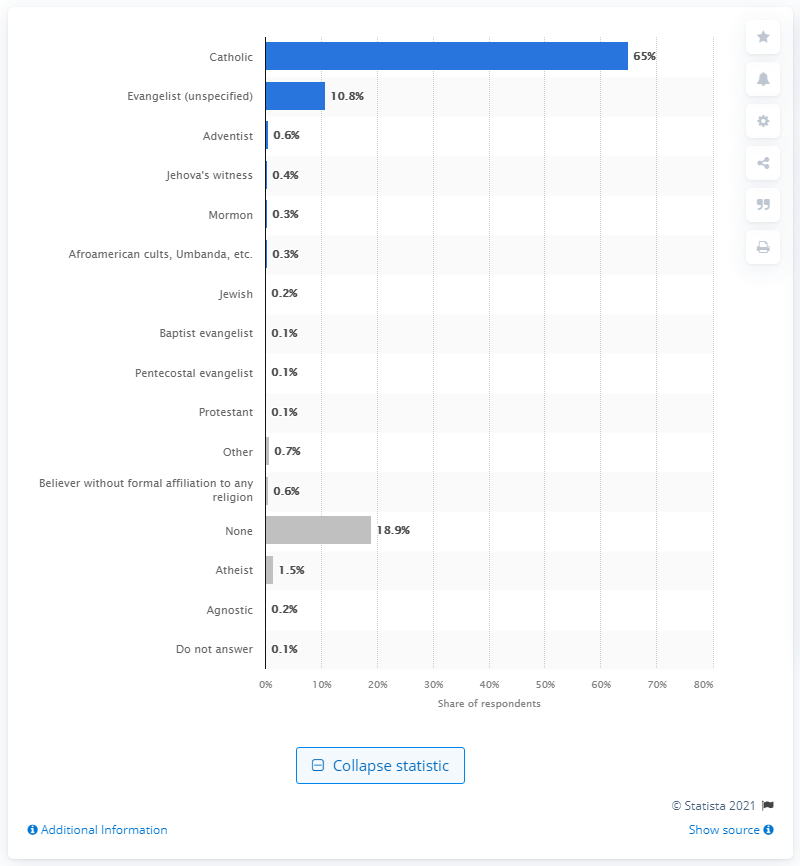List a handful of essential elements in this visual. According to the survey, 1.5% of Argentinian respondents identified as atheists. 